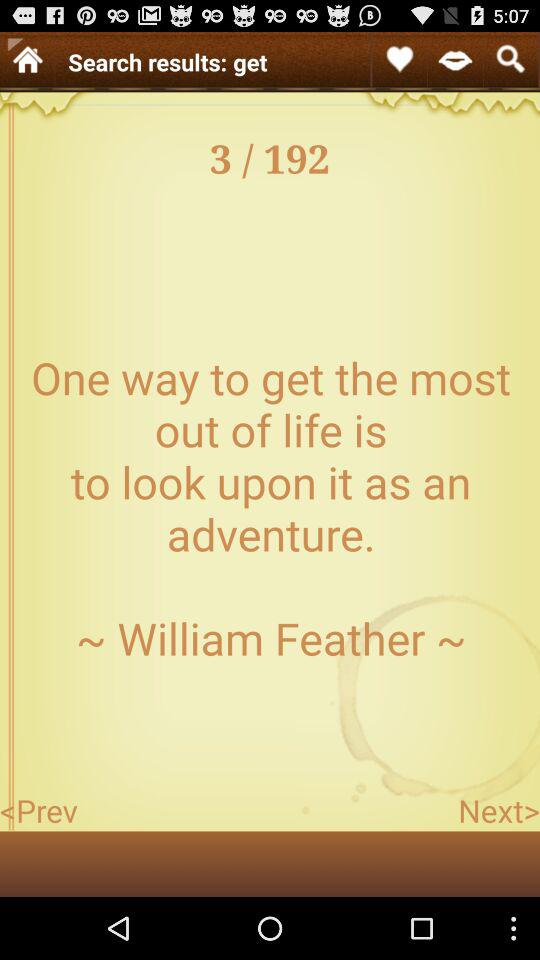How many pages in total are there? There are 192 pages in total. 